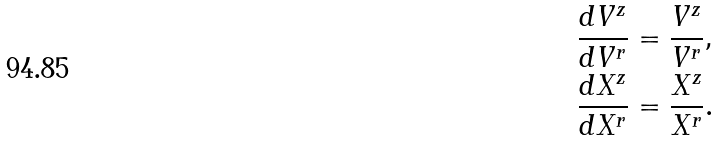Convert formula to latex. <formula><loc_0><loc_0><loc_500><loc_500>\frac { d V ^ { z } } { d V ^ { r } } & = \frac { V ^ { z } } { V ^ { r } } , \\ \frac { d X ^ { z } } { d X ^ { r } } & = \frac { X ^ { z } } { X ^ { r } } .</formula> 